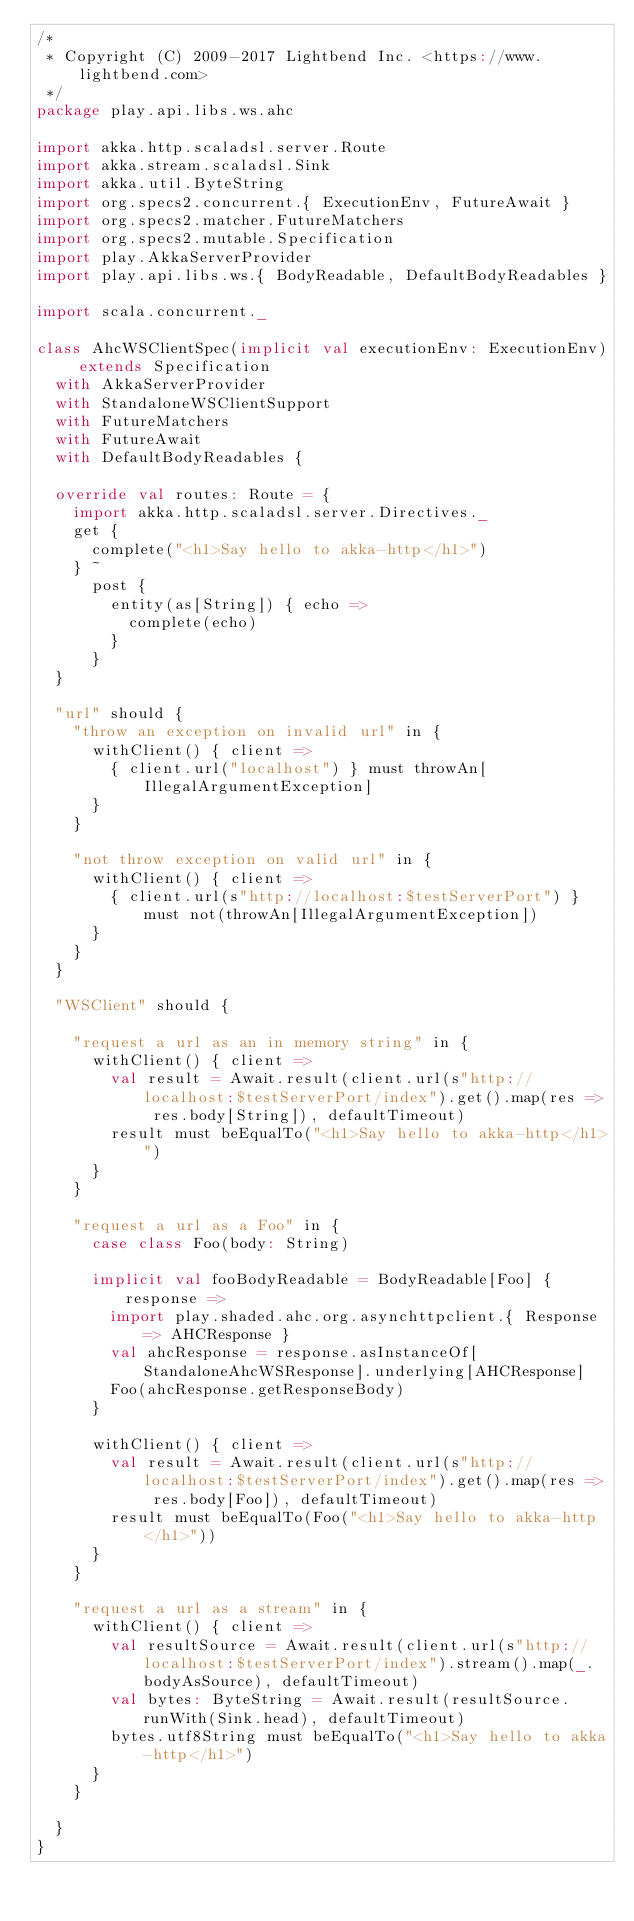Convert code to text. <code><loc_0><loc_0><loc_500><loc_500><_Scala_>/*
 * Copyright (C) 2009-2017 Lightbend Inc. <https://www.lightbend.com>
 */
package play.api.libs.ws.ahc

import akka.http.scaladsl.server.Route
import akka.stream.scaladsl.Sink
import akka.util.ByteString
import org.specs2.concurrent.{ ExecutionEnv, FutureAwait }
import org.specs2.matcher.FutureMatchers
import org.specs2.mutable.Specification
import play.AkkaServerProvider
import play.api.libs.ws.{ BodyReadable, DefaultBodyReadables }

import scala.concurrent._

class AhcWSClientSpec(implicit val executionEnv: ExecutionEnv) extends Specification
  with AkkaServerProvider
  with StandaloneWSClientSupport
  with FutureMatchers
  with FutureAwait
  with DefaultBodyReadables {

  override val routes: Route = {
    import akka.http.scaladsl.server.Directives._
    get {
      complete("<h1>Say hello to akka-http</h1>")
    } ~
      post {
        entity(as[String]) { echo =>
          complete(echo)
        }
      }
  }

  "url" should {
    "throw an exception on invalid url" in {
      withClient() { client =>
        { client.url("localhost") } must throwAn[IllegalArgumentException]
      }
    }

    "not throw exception on valid url" in {
      withClient() { client =>
        { client.url(s"http://localhost:$testServerPort") } must not(throwAn[IllegalArgumentException])
      }
    }
  }

  "WSClient" should {

    "request a url as an in memory string" in {
      withClient() { client =>
        val result = Await.result(client.url(s"http://localhost:$testServerPort/index").get().map(res => res.body[String]), defaultTimeout)
        result must beEqualTo("<h1>Say hello to akka-http</h1>")
      }
    }

    "request a url as a Foo" in {
      case class Foo(body: String)

      implicit val fooBodyReadable = BodyReadable[Foo] { response =>
        import play.shaded.ahc.org.asynchttpclient.{ Response => AHCResponse }
        val ahcResponse = response.asInstanceOf[StandaloneAhcWSResponse].underlying[AHCResponse]
        Foo(ahcResponse.getResponseBody)
      }

      withClient() { client =>
        val result = Await.result(client.url(s"http://localhost:$testServerPort/index").get().map(res => res.body[Foo]), defaultTimeout)
        result must beEqualTo(Foo("<h1>Say hello to akka-http</h1>"))
      }
    }

    "request a url as a stream" in {
      withClient() { client =>
        val resultSource = Await.result(client.url(s"http://localhost:$testServerPort/index").stream().map(_.bodyAsSource), defaultTimeout)
        val bytes: ByteString = Await.result(resultSource.runWith(Sink.head), defaultTimeout)
        bytes.utf8String must beEqualTo("<h1>Say hello to akka-http</h1>")
      }
    }

  }
}
</code> 